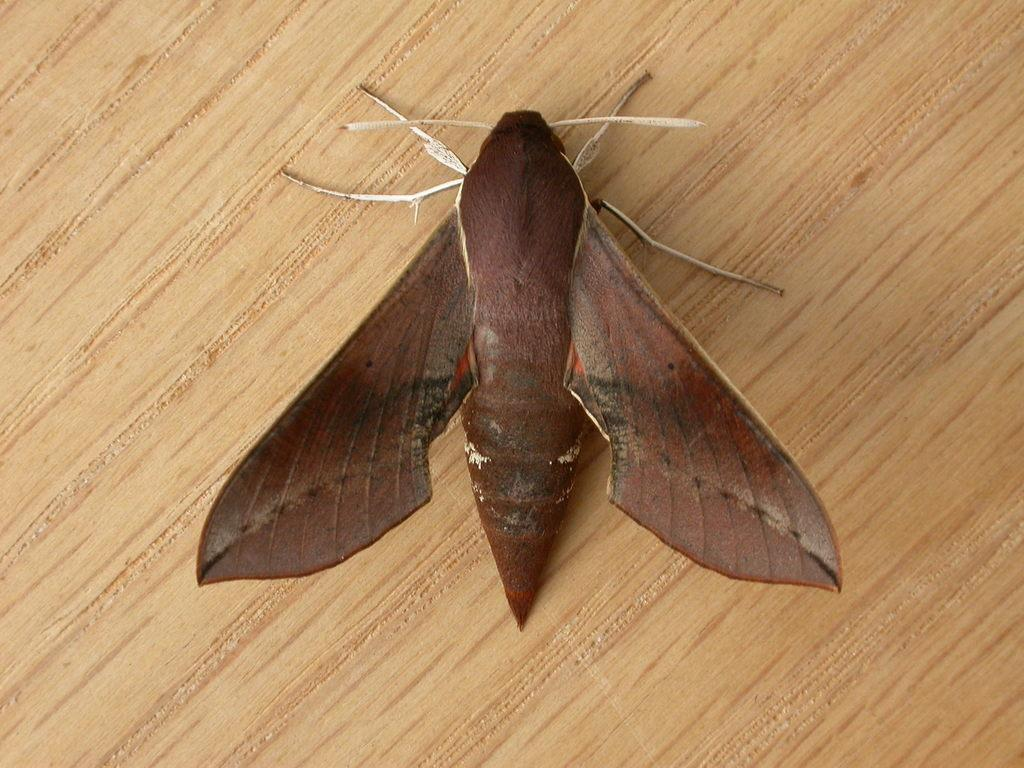What type of insect is present in the image? There is a brown butterfly in the image. Where is the butterfly located? The butterfly is sitting on a wooden table top. How many rabbits are visible in the image? There are no rabbits present in the image; it features a brown butterfly on a wooden table top. What type of material is the wool made of in the image? There is no wool present in the image. 